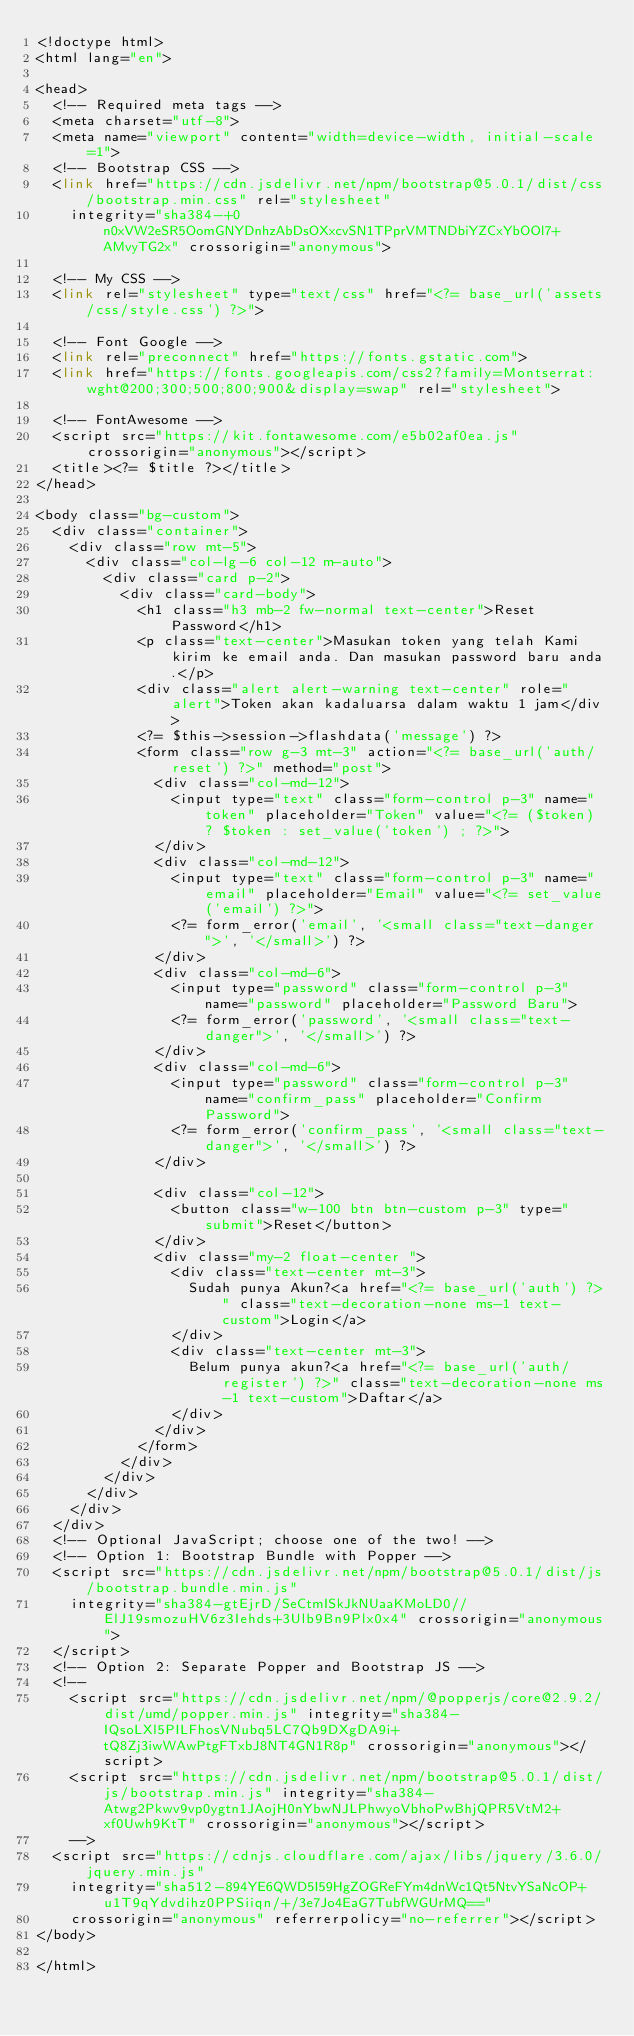<code> <loc_0><loc_0><loc_500><loc_500><_PHP_><!doctype html>
<html lang="en">

<head>
  <!-- Required meta tags -->
  <meta charset="utf-8">
  <meta name="viewport" content="width=device-width, initial-scale=1">
  <!-- Bootstrap CSS -->
  <link href="https://cdn.jsdelivr.net/npm/bootstrap@5.0.1/dist/css/bootstrap.min.css" rel="stylesheet"
    integrity="sha384-+0n0xVW2eSR5OomGNYDnhzAbDsOXxcvSN1TPprVMTNDbiYZCxYbOOl7+AMvyTG2x" crossorigin="anonymous">

  <!-- My CSS -->
  <link rel="stylesheet" type="text/css" href="<?= base_url('assets/css/style.css') ?>">

  <!-- Font Google -->
  <link rel="preconnect" href="https://fonts.gstatic.com">
  <link href="https://fonts.googleapis.com/css2?family=Montserrat:wght@200;300;500;800;900&display=swap" rel="stylesheet">

  <!-- FontAwesome -->
  <script src="https://kit.fontawesome.com/e5b02af0ea.js" crossorigin="anonymous"></script>
  <title><?= $title ?></title>
</head>

<body class="bg-custom">
  <div class="container">
    <div class="row mt-5">
      <div class="col-lg-6 col-12 m-auto">
        <div class="card p-2">
          <div class="card-body">
            <h1 class="h3 mb-2 fw-normal text-center">Reset Password</h1>
            <p class="text-center">Masukan token yang telah Kami kirim ke email anda. Dan masukan password baru anda.</p>
            <div class="alert alert-warning text-center" role="alert">Token akan kadaluarsa dalam waktu 1 jam</div>
            <?= $this->session->flashdata('message') ?>
            <form class="row g-3 mt-3" action="<?= base_url('auth/reset') ?>" method="post">
              <div class="col-md-12">
                <input type="text" class="form-control p-3" name="token" placeholder="Token" value="<?= ($token) ? $token : set_value('token') ; ?>">
              </div>
              <div class="col-md-12">
                <input type="text" class="form-control p-3" name="email" placeholder="Email" value="<?= set_value('email') ?>">
                <?= form_error('email', '<small class="text-danger">', '</small>') ?>
              </div>
              <div class="col-md-6">
                <input type="password" class="form-control p-3" name="password" placeholder="Password Baru">
                <?= form_error('password', '<small class="text-danger">', '</small>') ?>
              </div>
              <div class="col-md-6">
                <input type="password" class="form-control p-3" name="confirm_pass" placeholder="Confirm Password">
                <?= form_error('confirm_pass', '<small class="text-danger">', '</small>') ?>
              </div>
              
              <div class="col-12">
                <button class="w-100 btn btn-custom p-3" type="submit">Reset</button>
              </div>
              <div class="my-2 float-center ">
                <div class="text-center mt-3">
                  Sudah punya Akun?<a href="<?= base_url('auth') ?>" class="text-decoration-none ms-1 text-custom">Login</a>
                </div>
                <div class="text-center mt-3">
                  Belum punya akun?<a href="<?= base_url('auth/register') ?>" class="text-decoration-none ms-1 text-custom">Daftar</a>
                </div>
              </div>
            </form>
          </div>
        </div>
      </div>
    </div>
  </div>
  <!-- Optional JavaScript; choose one of the two! -->
  <!-- Option 1: Bootstrap Bundle with Popper -->
  <script src="https://cdn.jsdelivr.net/npm/bootstrap@5.0.1/dist/js/bootstrap.bundle.min.js"
    integrity="sha384-gtEjrD/SeCtmISkJkNUaaKMoLD0//ElJ19smozuHV6z3Iehds+3Ulb9Bn9Plx0x4" crossorigin="anonymous">
  </script>
  <!-- Option 2: Separate Popper and Bootstrap JS -->
  <!--
    <script src="https://cdn.jsdelivr.net/npm/@popperjs/core@2.9.2/dist/umd/popper.min.js" integrity="sha384-IQsoLXl5PILFhosVNubq5LC7Qb9DXgDA9i+tQ8Zj3iwWAwPtgFTxbJ8NT4GN1R8p" crossorigin="anonymous"></script>
    <script src="https://cdn.jsdelivr.net/npm/bootstrap@5.0.1/dist/js/bootstrap.min.js" integrity="sha384-Atwg2Pkwv9vp0ygtn1JAojH0nYbwNJLPhwyoVbhoPwBhjQPR5VtM2+xf0Uwh9KtT" crossorigin="anonymous"></script>
    -->
  <script src="https://cdnjs.cloudflare.com/ajax/libs/jquery/3.6.0/jquery.min.js"
    integrity="sha512-894YE6QWD5I59HgZOGReFYm4dnWc1Qt5NtvYSaNcOP+u1T9qYdvdihz0PPSiiqn/+/3e7Jo4EaG7TubfWGUrMQ=="
    crossorigin="anonymous" referrerpolicy="no-referrer"></script>
</body>

</html></code> 